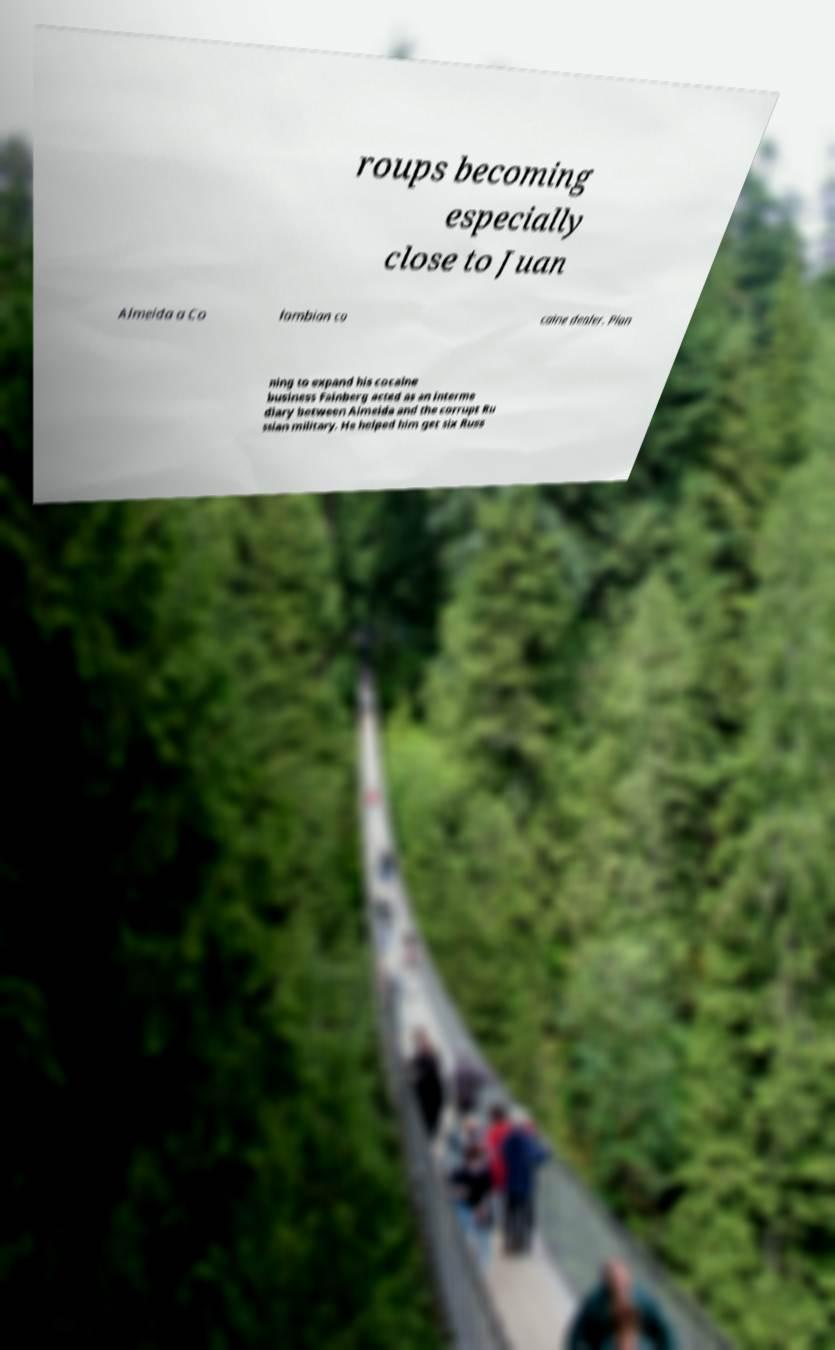I need the written content from this picture converted into text. Can you do that? roups becoming especially close to Juan Almeida a Co lombian co caine dealer. Plan ning to expand his cocaine business Fainberg acted as an interme diary between Almeida and the corrupt Ru ssian military. He helped him get six Russ 